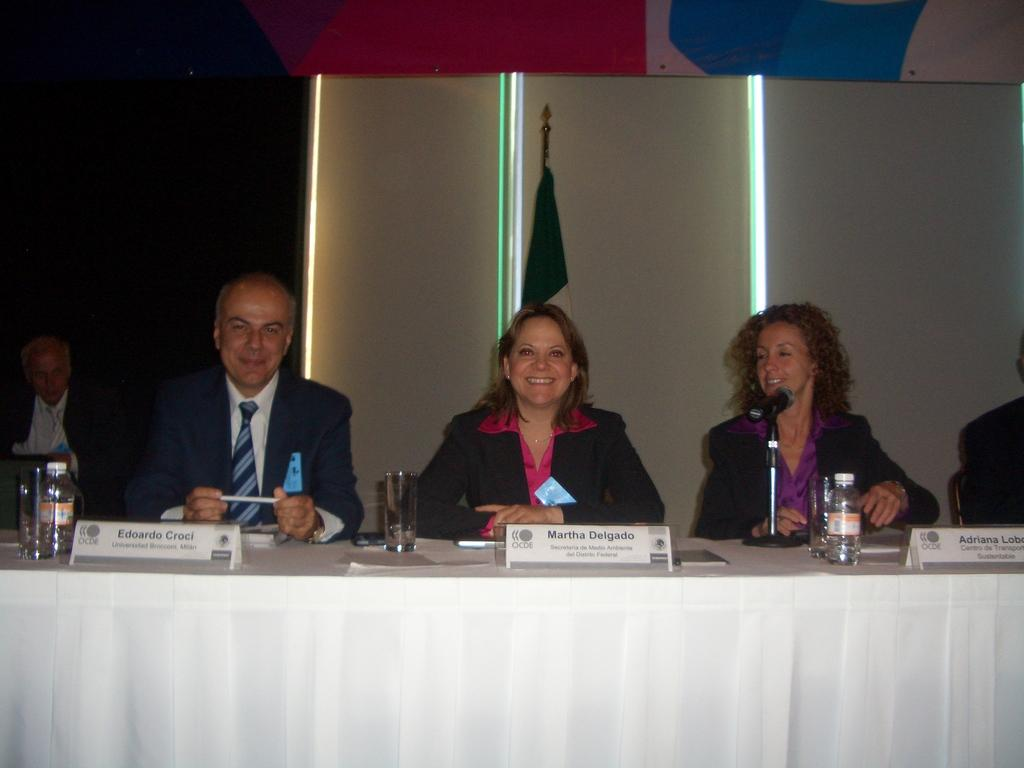What are the people sitting in front of in the image? The people are sitting in front of a table. What items can be seen on the table? There are bottles, glasses, a microphone (mic), and name cards on the table. What is the purpose of the name cards on the table? The name cards correspond to the people sitting at the table. Is there any symbol or emblem visible in the image? Yes, there is a flag visible in the image. Where is the cactus located in the image? There is no cactus present in the image. What type of books can be seen in the library depicted in the image? There is no library depicted in the image. 